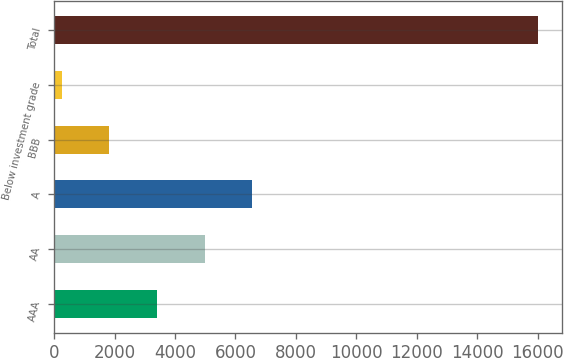<chart> <loc_0><loc_0><loc_500><loc_500><bar_chart><fcel>AAA<fcel>AA<fcel>A<fcel>BBB<fcel>Below investment grade<fcel>Total<nl><fcel>3401<fcel>4976<fcel>6551<fcel>1826<fcel>251<fcel>16001<nl></chart> 